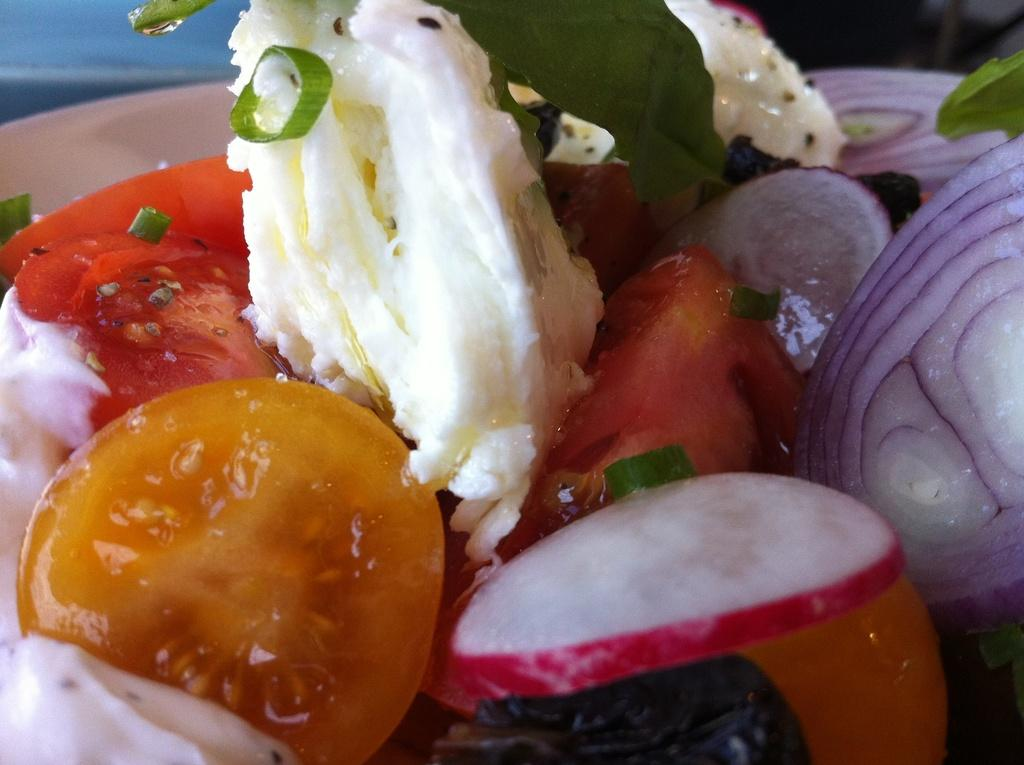What color is the plate that is visible in the image? The plate is white in color. What is on the plate in the image? The plate contains food items. Can you see the moon in the image? No, the moon is not present in the image. Is there a visitor sitting at the table in the image? There is no information about a visitor in the image; it only shows a white color plate with food items. 